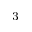<formula> <loc_0><loc_0><loc_500><loc_500>^ { 3 }</formula> 